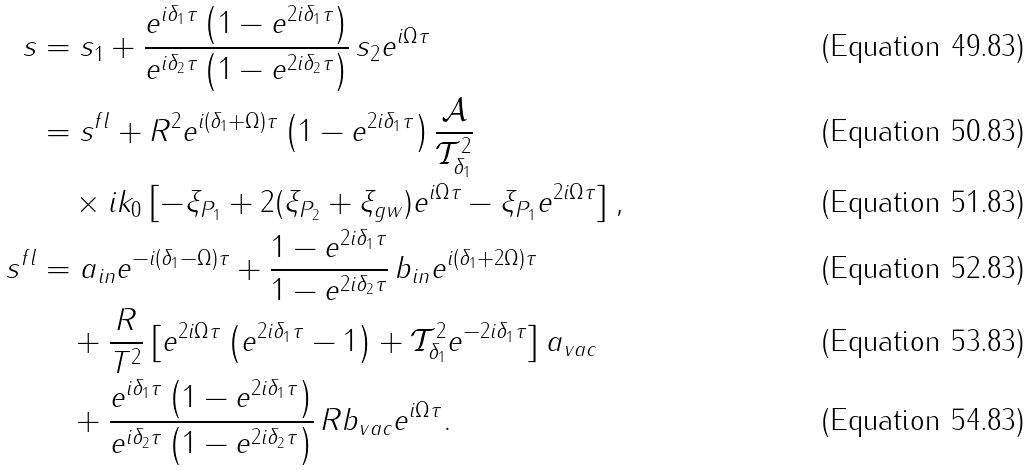Convert formula to latex. <formula><loc_0><loc_0><loc_500><loc_500>s & = s _ { 1 } + \frac { e ^ { i \delta _ { 1 } \tau } \left ( 1 - e ^ { 2 i \delta _ { 1 } \tau } \right ) } { e ^ { i \delta _ { 2 } \tau } \left ( 1 - e ^ { 2 i \delta _ { 2 } \tau } \right ) } \, s _ { 2 } e ^ { i \Omega \tau } \\ & = s ^ { f l } + R ^ { 2 } e ^ { i ( \delta _ { 1 } + \Omega ) \tau } \left ( 1 - e ^ { 2 i \delta _ { 1 } \tau } \right ) \frac { \mathcal { A } } { \mathcal { T } ^ { 2 } _ { \delta _ { 1 } } } \\ & \quad \times i k _ { 0 } \left [ - \xi _ { P _ { 1 } } + 2 ( \xi _ { P _ { 2 } } + \xi _ { g w } ) e ^ { i \Omega \tau } - \xi _ { P _ { 1 } } e ^ { 2 i \Omega \tau } \right ] , \\ s ^ { f l } & = a _ { i n } e ^ { - i ( \delta _ { 1 } - \Omega ) \tau } + \frac { 1 - e ^ { 2 i \delta _ { 1 } \tau } } { 1 - e ^ { 2 i \delta _ { 2 } \tau } } \, b _ { i n } e ^ { i ( \delta _ { 1 } + 2 \Omega ) \tau } \\ & \quad + \frac { R } { T ^ { 2 } } \left [ e ^ { 2 i \Omega \tau } \left ( e ^ { 2 i \delta _ { 1 } \tau } - 1 \right ) + \mathcal { T } ^ { 2 } _ { \delta _ { 1 } } e ^ { - 2 i \delta _ { 1 } \tau } \right ] a _ { v a c } \\ & \quad + \frac { e ^ { i \delta _ { 1 } \tau } \left ( 1 - e ^ { 2 i \delta _ { 1 } \tau } \right ) } { e ^ { i \delta _ { 2 } \tau } \left ( 1 - e ^ { 2 i \delta _ { 2 } \tau } \right ) } \, R b _ { v a c } e ^ { i \Omega \tau } .</formula> 